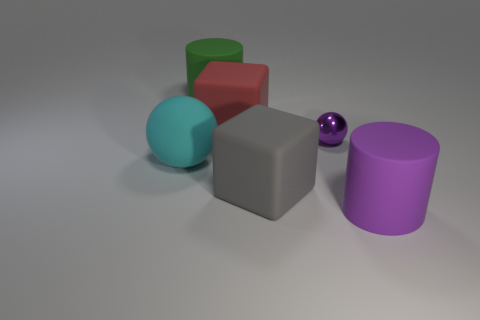Add 3 green matte cylinders. How many objects exist? 9 Subtract all cylinders. How many objects are left? 4 Add 5 big purple matte things. How many big purple matte things are left? 6 Add 6 small metal balls. How many small metal balls exist? 7 Subtract 1 gray blocks. How many objects are left? 5 Subtract all large brown shiny cylinders. Subtract all large green matte things. How many objects are left? 5 